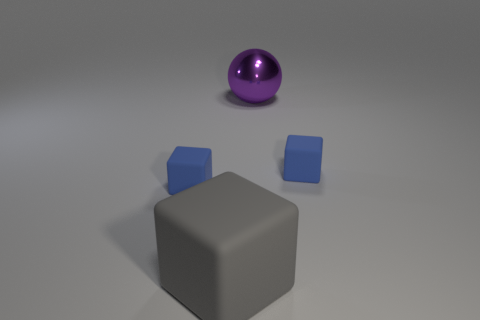Are there any other things that are the same material as the purple ball?
Provide a short and direct response. No. What number of gray cubes have the same material as the large purple thing?
Provide a succinct answer. 0. Do the small thing left of the purple metal thing and the big rubber object have the same color?
Keep it short and to the point. No. How many blue things are small rubber blocks or big matte cubes?
Your response must be concise. 2. Is the thing right of the sphere made of the same material as the purple sphere?
Give a very brief answer. No. What number of objects are either small matte cubes or big objects behind the big gray block?
Your response must be concise. 3. There is a small blue matte cube to the right of the large gray object that is on the left side of the big metallic thing; what number of objects are to the left of it?
Keep it short and to the point. 3. Does the tiny blue rubber object that is on the left side of the gray cube have the same shape as the big rubber object?
Provide a succinct answer. Yes. Are there any blue rubber cubes on the right side of the small blue matte thing to the left of the ball?
Your answer should be compact. Yes. What number of blue things are there?
Your answer should be compact. 2. 